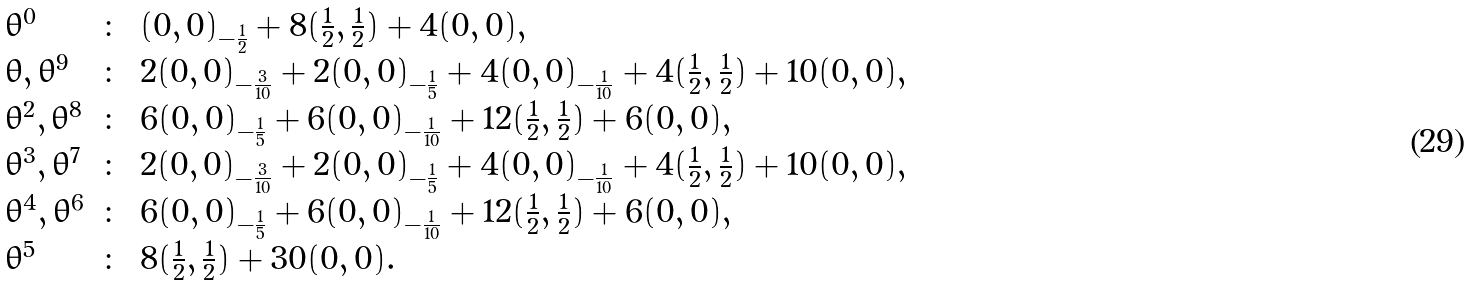Convert formula to latex. <formula><loc_0><loc_0><loc_500><loc_500>\begin{array} { l c l } \theta ^ { 0 } & \colon & ( 0 , 0 ) _ { - \frac { 1 } { 2 } } + 8 ( \frac { 1 } { 2 } , \frac { 1 } { 2 } ) + 4 ( 0 , 0 ) , \\ \theta , \theta ^ { 9 } & \colon & 2 ( 0 , 0 ) _ { - \frac { 3 } { 1 0 } } + 2 ( 0 , 0 ) _ { - \frac { 1 } { 5 } } + 4 ( 0 , 0 ) _ { - \frac { 1 } { 1 0 } } + 4 ( \frac { 1 } { 2 } , \frac { 1 } { 2 } ) + 1 0 ( 0 , 0 ) , \\ \theta ^ { 2 } , \theta ^ { 8 } & \colon & 6 ( 0 , 0 ) _ { - \frac { 1 } { 5 } } + 6 ( 0 , 0 ) _ { - \frac { 1 } { 1 0 } } + 1 2 ( \frac { 1 } { 2 } , \frac { 1 } { 2 } ) + 6 ( 0 , 0 ) , \\ \theta ^ { 3 } , \theta ^ { 7 } & \colon & 2 ( 0 , 0 ) _ { - \frac { 3 } { 1 0 } } + 2 ( 0 , 0 ) _ { - \frac { 1 } { 5 } } + 4 ( 0 , 0 ) _ { - \frac { 1 } { 1 0 } } + 4 ( \frac { 1 } { 2 } , \frac { 1 } { 2 } ) + 1 0 ( 0 , 0 ) , \\ \theta ^ { 4 } , \theta ^ { 6 } & \colon & 6 ( 0 , 0 ) _ { - \frac { 1 } { 5 } } + 6 ( 0 , 0 ) _ { - \frac { 1 } { 1 0 } } + 1 2 ( \frac { 1 } { 2 } , \frac { 1 } { 2 } ) + 6 ( 0 , 0 ) , \\ \theta ^ { 5 } & \colon & 8 ( \frac { 1 } { 2 } , \frac { 1 } { 2 } ) + 3 0 ( 0 , 0 ) . \end{array}</formula> 